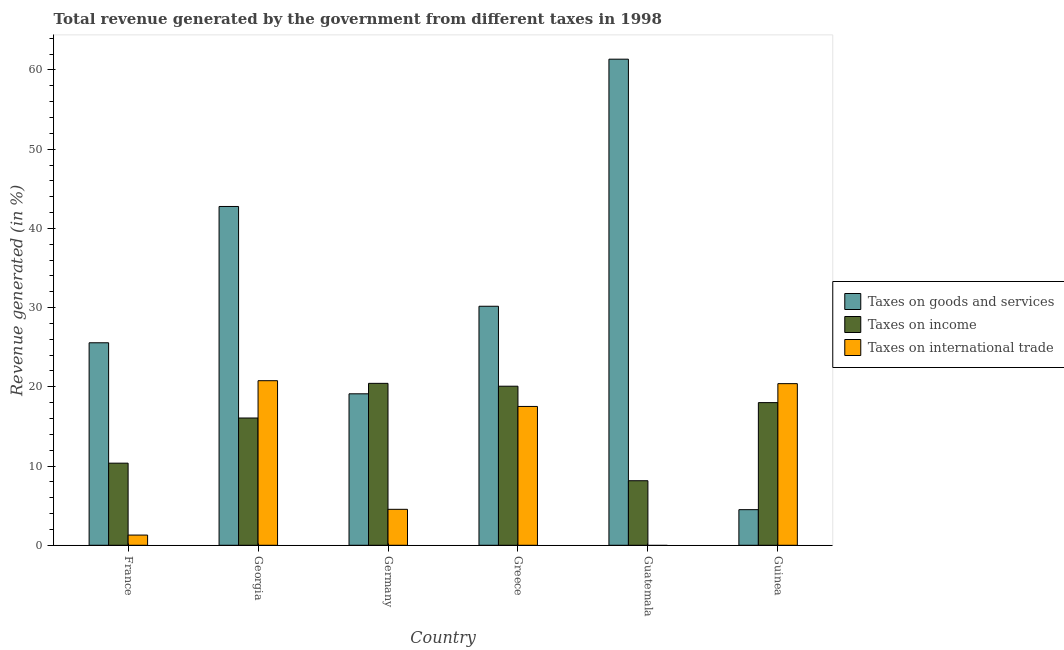How many groups of bars are there?
Your answer should be compact. 6. Are the number of bars per tick equal to the number of legend labels?
Give a very brief answer. No. Are the number of bars on each tick of the X-axis equal?
Provide a succinct answer. No. How many bars are there on the 1st tick from the left?
Your response must be concise. 3. How many bars are there on the 3rd tick from the right?
Provide a short and direct response. 3. What is the label of the 5th group of bars from the left?
Ensure brevity in your answer.  Guatemala. What is the percentage of revenue generated by tax on international trade in Guinea?
Keep it short and to the point. 20.4. Across all countries, what is the maximum percentage of revenue generated by taxes on goods and services?
Your answer should be compact. 61.36. Across all countries, what is the minimum percentage of revenue generated by taxes on goods and services?
Offer a very short reply. 4.5. In which country was the percentage of revenue generated by tax on international trade maximum?
Offer a terse response. Georgia. What is the total percentage of revenue generated by tax on international trade in the graph?
Provide a succinct answer. 64.53. What is the difference between the percentage of revenue generated by tax on international trade in France and that in Germany?
Ensure brevity in your answer.  -3.25. What is the difference between the percentage of revenue generated by taxes on goods and services in Georgia and the percentage of revenue generated by taxes on income in Greece?
Make the answer very short. 22.69. What is the average percentage of revenue generated by tax on international trade per country?
Ensure brevity in your answer.  10.75. What is the difference between the percentage of revenue generated by taxes on income and percentage of revenue generated by taxes on goods and services in Greece?
Make the answer very short. -10.09. In how many countries, is the percentage of revenue generated by taxes on goods and services greater than 48 %?
Your answer should be compact. 1. What is the ratio of the percentage of revenue generated by taxes on income in France to that in Georgia?
Keep it short and to the point. 0.65. Is the percentage of revenue generated by taxes on goods and services in Germany less than that in Guinea?
Keep it short and to the point. No. What is the difference between the highest and the second highest percentage of revenue generated by tax on international trade?
Give a very brief answer. 0.37. What is the difference between the highest and the lowest percentage of revenue generated by taxes on income?
Your response must be concise. 12.29. Is it the case that in every country, the sum of the percentage of revenue generated by taxes on goods and services and percentage of revenue generated by taxes on income is greater than the percentage of revenue generated by tax on international trade?
Your answer should be very brief. Yes. How many bars are there?
Your answer should be compact. 17. Are all the bars in the graph horizontal?
Keep it short and to the point. No. How many countries are there in the graph?
Provide a short and direct response. 6. Are the values on the major ticks of Y-axis written in scientific E-notation?
Your answer should be very brief. No. Does the graph contain any zero values?
Your answer should be very brief. Yes. How many legend labels are there?
Your answer should be very brief. 3. How are the legend labels stacked?
Provide a short and direct response. Vertical. What is the title of the graph?
Provide a succinct answer. Total revenue generated by the government from different taxes in 1998. What is the label or title of the Y-axis?
Provide a short and direct response. Revenue generated (in %). What is the Revenue generated (in %) in Taxes on goods and services in France?
Ensure brevity in your answer.  25.56. What is the Revenue generated (in %) in Taxes on income in France?
Make the answer very short. 10.37. What is the Revenue generated (in %) in Taxes on international trade in France?
Ensure brevity in your answer.  1.29. What is the Revenue generated (in %) in Taxes on goods and services in Georgia?
Keep it short and to the point. 42.77. What is the Revenue generated (in %) of Taxes on income in Georgia?
Provide a short and direct response. 16.06. What is the Revenue generated (in %) of Taxes on international trade in Georgia?
Keep it short and to the point. 20.77. What is the Revenue generated (in %) in Taxes on goods and services in Germany?
Your answer should be very brief. 19.12. What is the Revenue generated (in %) in Taxes on income in Germany?
Ensure brevity in your answer.  20.44. What is the Revenue generated (in %) in Taxes on international trade in Germany?
Give a very brief answer. 4.54. What is the Revenue generated (in %) in Taxes on goods and services in Greece?
Provide a succinct answer. 30.17. What is the Revenue generated (in %) of Taxes on income in Greece?
Provide a succinct answer. 20.08. What is the Revenue generated (in %) in Taxes on international trade in Greece?
Offer a terse response. 17.52. What is the Revenue generated (in %) of Taxes on goods and services in Guatemala?
Offer a terse response. 61.36. What is the Revenue generated (in %) of Taxes on income in Guatemala?
Your response must be concise. 8.15. What is the Revenue generated (in %) in Taxes on international trade in Guatemala?
Your response must be concise. 0. What is the Revenue generated (in %) of Taxes on goods and services in Guinea?
Your answer should be very brief. 4.5. What is the Revenue generated (in %) in Taxes on income in Guinea?
Provide a short and direct response. 18.01. What is the Revenue generated (in %) in Taxes on international trade in Guinea?
Offer a terse response. 20.4. Across all countries, what is the maximum Revenue generated (in %) in Taxes on goods and services?
Give a very brief answer. 61.36. Across all countries, what is the maximum Revenue generated (in %) in Taxes on income?
Provide a short and direct response. 20.44. Across all countries, what is the maximum Revenue generated (in %) in Taxes on international trade?
Offer a very short reply. 20.77. Across all countries, what is the minimum Revenue generated (in %) of Taxes on goods and services?
Your answer should be compact. 4.5. Across all countries, what is the minimum Revenue generated (in %) of Taxes on income?
Offer a terse response. 8.15. Across all countries, what is the minimum Revenue generated (in %) in Taxes on international trade?
Offer a terse response. 0. What is the total Revenue generated (in %) in Taxes on goods and services in the graph?
Keep it short and to the point. 183.47. What is the total Revenue generated (in %) in Taxes on income in the graph?
Make the answer very short. 93.1. What is the total Revenue generated (in %) of Taxes on international trade in the graph?
Provide a succinct answer. 64.53. What is the difference between the Revenue generated (in %) of Taxes on goods and services in France and that in Georgia?
Provide a succinct answer. -17.2. What is the difference between the Revenue generated (in %) in Taxes on income in France and that in Georgia?
Make the answer very short. -5.7. What is the difference between the Revenue generated (in %) of Taxes on international trade in France and that in Georgia?
Offer a terse response. -19.49. What is the difference between the Revenue generated (in %) in Taxes on goods and services in France and that in Germany?
Your response must be concise. 6.44. What is the difference between the Revenue generated (in %) of Taxes on income in France and that in Germany?
Make the answer very short. -10.07. What is the difference between the Revenue generated (in %) of Taxes on international trade in France and that in Germany?
Provide a succinct answer. -3.25. What is the difference between the Revenue generated (in %) in Taxes on goods and services in France and that in Greece?
Ensure brevity in your answer.  -4.61. What is the difference between the Revenue generated (in %) of Taxes on income in France and that in Greece?
Make the answer very short. -9.71. What is the difference between the Revenue generated (in %) in Taxes on international trade in France and that in Greece?
Give a very brief answer. -16.23. What is the difference between the Revenue generated (in %) of Taxes on goods and services in France and that in Guatemala?
Make the answer very short. -35.8. What is the difference between the Revenue generated (in %) of Taxes on income in France and that in Guatemala?
Make the answer very short. 2.22. What is the difference between the Revenue generated (in %) of Taxes on goods and services in France and that in Guinea?
Provide a succinct answer. 21.07. What is the difference between the Revenue generated (in %) of Taxes on income in France and that in Guinea?
Provide a short and direct response. -7.64. What is the difference between the Revenue generated (in %) in Taxes on international trade in France and that in Guinea?
Your answer should be very brief. -19.11. What is the difference between the Revenue generated (in %) of Taxes on goods and services in Georgia and that in Germany?
Your answer should be very brief. 23.65. What is the difference between the Revenue generated (in %) of Taxes on income in Georgia and that in Germany?
Give a very brief answer. -4.37. What is the difference between the Revenue generated (in %) of Taxes on international trade in Georgia and that in Germany?
Offer a terse response. 16.23. What is the difference between the Revenue generated (in %) of Taxes on goods and services in Georgia and that in Greece?
Give a very brief answer. 12.6. What is the difference between the Revenue generated (in %) in Taxes on income in Georgia and that in Greece?
Provide a short and direct response. -4.01. What is the difference between the Revenue generated (in %) in Taxes on international trade in Georgia and that in Greece?
Keep it short and to the point. 3.25. What is the difference between the Revenue generated (in %) of Taxes on goods and services in Georgia and that in Guatemala?
Provide a succinct answer. -18.59. What is the difference between the Revenue generated (in %) in Taxes on income in Georgia and that in Guatemala?
Offer a terse response. 7.92. What is the difference between the Revenue generated (in %) of Taxes on goods and services in Georgia and that in Guinea?
Provide a short and direct response. 38.27. What is the difference between the Revenue generated (in %) of Taxes on income in Georgia and that in Guinea?
Your answer should be compact. -1.94. What is the difference between the Revenue generated (in %) in Taxes on international trade in Georgia and that in Guinea?
Keep it short and to the point. 0.37. What is the difference between the Revenue generated (in %) in Taxes on goods and services in Germany and that in Greece?
Provide a succinct answer. -11.05. What is the difference between the Revenue generated (in %) in Taxes on income in Germany and that in Greece?
Keep it short and to the point. 0.36. What is the difference between the Revenue generated (in %) in Taxes on international trade in Germany and that in Greece?
Provide a short and direct response. -12.98. What is the difference between the Revenue generated (in %) of Taxes on goods and services in Germany and that in Guatemala?
Your answer should be very brief. -42.24. What is the difference between the Revenue generated (in %) in Taxes on income in Germany and that in Guatemala?
Provide a short and direct response. 12.29. What is the difference between the Revenue generated (in %) in Taxes on goods and services in Germany and that in Guinea?
Keep it short and to the point. 14.62. What is the difference between the Revenue generated (in %) in Taxes on income in Germany and that in Guinea?
Your response must be concise. 2.43. What is the difference between the Revenue generated (in %) of Taxes on international trade in Germany and that in Guinea?
Your response must be concise. -15.86. What is the difference between the Revenue generated (in %) in Taxes on goods and services in Greece and that in Guatemala?
Your answer should be compact. -31.19. What is the difference between the Revenue generated (in %) in Taxes on income in Greece and that in Guatemala?
Offer a terse response. 11.93. What is the difference between the Revenue generated (in %) in Taxes on goods and services in Greece and that in Guinea?
Provide a succinct answer. 25.67. What is the difference between the Revenue generated (in %) in Taxes on income in Greece and that in Guinea?
Provide a short and direct response. 2.07. What is the difference between the Revenue generated (in %) of Taxes on international trade in Greece and that in Guinea?
Give a very brief answer. -2.88. What is the difference between the Revenue generated (in %) of Taxes on goods and services in Guatemala and that in Guinea?
Keep it short and to the point. 56.86. What is the difference between the Revenue generated (in %) of Taxes on income in Guatemala and that in Guinea?
Make the answer very short. -9.86. What is the difference between the Revenue generated (in %) of Taxes on goods and services in France and the Revenue generated (in %) of Taxes on income in Georgia?
Ensure brevity in your answer.  9.5. What is the difference between the Revenue generated (in %) of Taxes on goods and services in France and the Revenue generated (in %) of Taxes on international trade in Georgia?
Keep it short and to the point. 4.79. What is the difference between the Revenue generated (in %) of Taxes on income in France and the Revenue generated (in %) of Taxes on international trade in Georgia?
Ensure brevity in your answer.  -10.41. What is the difference between the Revenue generated (in %) in Taxes on goods and services in France and the Revenue generated (in %) in Taxes on income in Germany?
Make the answer very short. 5.12. What is the difference between the Revenue generated (in %) of Taxes on goods and services in France and the Revenue generated (in %) of Taxes on international trade in Germany?
Ensure brevity in your answer.  21.02. What is the difference between the Revenue generated (in %) of Taxes on income in France and the Revenue generated (in %) of Taxes on international trade in Germany?
Your response must be concise. 5.83. What is the difference between the Revenue generated (in %) of Taxes on goods and services in France and the Revenue generated (in %) of Taxes on income in Greece?
Your answer should be compact. 5.48. What is the difference between the Revenue generated (in %) of Taxes on goods and services in France and the Revenue generated (in %) of Taxes on international trade in Greece?
Offer a terse response. 8.04. What is the difference between the Revenue generated (in %) in Taxes on income in France and the Revenue generated (in %) in Taxes on international trade in Greece?
Your response must be concise. -7.16. What is the difference between the Revenue generated (in %) in Taxes on goods and services in France and the Revenue generated (in %) in Taxes on income in Guatemala?
Provide a short and direct response. 17.41. What is the difference between the Revenue generated (in %) in Taxes on goods and services in France and the Revenue generated (in %) in Taxes on income in Guinea?
Provide a succinct answer. 7.55. What is the difference between the Revenue generated (in %) in Taxes on goods and services in France and the Revenue generated (in %) in Taxes on international trade in Guinea?
Keep it short and to the point. 5.16. What is the difference between the Revenue generated (in %) of Taxes on income in France and the Revenue generated (in %) of Taxes on international trade in Guinea?
Provide a succinct answer. -10.04. What is the difference between the Revenue generated (in %) in Taxes on goods and services in Georgia and the Revenue generated (in %) in Taxes on income in Germany?
Offer a very short reply. 22.33. What is the difference between the Revenue generated (in %) in Taxes on goods and services in Georgia and the Revenue generated (in %) in Taxes on international trade in Germany?
Provide a succinct answer. 38.23. What is the difference between the Revenue generated (in %) in Taxes on income in Georgia and the Revenue generated (in %) in Taxes on international trade in Germany?
Make the answer very short. 11.53. What is the difference between the Revenue generated (in %) in Taxes on goods and services in Georgia and the Revenue generated (in %) in Taxes on income in Greece?
Your answer should be very brief. 22.69. What is the difference between the Revenue generated (in %) of Taxes on goods and services in Georgia and the Revenue generated (in %) of Taxes on international trade in Greece?
Provide a succinct answer. 25.24. What is the difference between the Revenue generated (in %) in Taxes on income in Georgia and the Revenue generated (in %) in Taxes on international trade in Greece?
Ensure brevity in your answer.  -1.46. What is the difference between the Revenue generated (in %) of Taxes on goods and services in Georgia and the Revenue generated (in %) of Taxes on income in Guatemala?
Your response must be concise. 34.62. What is the difference between the Revenue generated (in %) in Taxes on goods and services in Georgia and the Revenue generated (in %) in Taxes on income in Guinea?
Give a very brief answer. 24.76. What is the difference between the Revenue generated (in %) in Taxes on goods and services in Georgia and the Revenue generated (in %) in Taxes on international trade in Guinea?
Give a very brief answer. 22.36. What is the difference between the Revenue generated (in %) in Taxes on income in Georgia and the Revenue generated (in %) in Taxes on international trade in Guinea?
Offer a very short reply. -4.34. What is the difference between the Revenue generated (in %) of Taxes on goods and services in Germany and the Revenue generated (in %) of Taxes on income in Greece?
Give a very brief answer. -0.96. What is the difference between the Revenue generated (in %) in Taxes on goods and services in Germany and the Revenue generated (in %) in Taxes on international trade in Greece?
Make the answer very short. 1.6. What is the difference between the Revenue generated (in %) in Taxes on income in Germany and the Revenue generated (in %) in Taxes on international trade in Greece?
Ensure brevity in your answer.  2.92. What is the difference between the Revenue generated (in %) of Taxes on goods and services in Germany and the Revenue generated (in %) of Taxes on income in Guatemala?
Provide a succinct answer. 10.97. What is the difference between the Revenue generated (in %) of Taxes on goods and services in Germany and the Revenue generated (in %) of Taxes on income in Guinea?
Your response must be concise. 1.11. What is the difference between the Revenue generated (in %) in Taxes on goods and services in Germany and the Revenue generated (in %) in Taxes on international trade in Guinea?
Offer a terse response. -1.28. What is the difference between the Revenue generated (in %) in Taxes on income in Germany and the Revenue generated (in %) in Taxes on international trade in Guinea?
Provide a succinct answer. 0.04. What is the difference between the Revenue generated (in %) in Taxes on goods and services in Greece and the Revenue generated (in %) in Taxes on income in Guatemala?
Your answer should be compact. 22.02. What is the difference between the Revenue generated (in %) of Taxes on goods and services in Greece and the Revenue generated (in %) of Taxes on income in Guinea?
Your answer should be very brief. 12.16. What is the difference between the Revenue generated (in %) in Taxes on goods and services in Greece and the Revenue generated (in %) in Taxes on international trade in Guinea?
Ensure brevity in your answer.  9.77. What is the difference between the Revenue generated (in %) in Taxes on income in Greece and the Revenue generated (in %) in Taxes on international trade in Guinea?
Offer a very short reply. -0.32. What is the difference between the Revenue generated (in %) of Taxes on goods and services in Guatemala and the Revenue generated (in %) of Taxes on income in Guinea?
Offer a very short reply. 43.35. What is the difference between the Revenue generated (in %) of Taxes on goods and services in Guatemala and the Revenue generated (in %) of Taxes on international trade in Guinea?
Your response must be concise. 40.96. What is the difference between the Revenue generated (in %) in Taxes on income in Guatemala and the Revenue generated (in %) in Taxes on international trade in Guinea?
Ensure brevity in your answer.  -12.25. What is the average Revenue generated (in %) in Taxes on goods and services per country?
Your response must be concise. 30.58. What is the average Revenue generated (in %) of Taxes on income per country?
Make the answer very short. 15.52. What is the average Revenue generated (in %) in Taxes on international trade per country?
Ensure brevity in your answer.  10.75. What is the difference between the Revenue generated (in %) in Taxes on goods and services and Revenue generated (in %) in Taxes on income in France?
Your answer should be compact. 15.2. What is the difference between the Revenue generated (in %) in Taxes on goods and services and Revenue generated (in %) in Taxes on international trade in France?
Provide a succinct answer. 24.27. What is the difference between the Revenue generated (in %) of Taxes on income and Revenue generated (in %) of Taxes on international trade in France?
Make the answer very short. 9.08. What is the difference between the Revenue generated (in %) in Taxes on goods and services and Revenue generated (in %) in Taxes on income in Georgia?
Your response must be concise. 26.7. What is the difference between the Revenue generated (in %) of Taxes on goods and services and Revenue generated (in %) of Taxes on international trade in Georgia?
Keep it short and to the point. 21.99. What is the difference between the Revenue generated (in %) in Taxes on income and Revenue generated (in %) in Taxes on international trade in Georgia?
Your response must be concise. -4.71. What is the difference between the Revenue generated (in %) of Taxes on goods and services and Revenue generated (in %) of Taxes on income in Germany?
Your answer should be very brief. -1.32. What is the difference between the Revenue generated (in %) of Taxes on goods and services and Revenue generated (in %) of Taxes on international trade in Germany?
Ensure brevity in your answer.  14.58. What is the difference between the Revenue generated (in %) in Taxes on income and Revenue generated (in %) in Taxes on international trade in Germany?
Keep it short and to the point. 15.9. What is the difference between the Revenue generated (in %) in Taxes on goods and services and Revenue generated (in %) in Taxes on income in Greece?
Provide a succinct answer. 10.09. What is the difference between the Revenue generated (in %) of Taxes on goods and services and Revenue generated (in %) of Taxes on international trade in Greece?
Your response must be concise. 12.65. What is the difference between the Revenue generated (in %) of Taxes on income and Revenue generated (in %) of Taxes on international trade in Greece?
Keep it short and to the point. 2.55. What is the difference between the Revenue generated (in %) of Taxes on goods and services and Revenue generated (in %) of Taxes on income in Guatemala?
Ensure brevity in your answer.  53.21. What is the difference between the Revenue generated (in %) of Taxes on goods and services and Revenue generated (in %) of Taxes on income in Guinea?
Your response must be concise. -13.51. What is the difference between the Revenue generated (in %) of Taxes on goods and services and Revenue generated (in %) of Taxes on international trade in Guinea?
Offer a very short reply. -15.91. What is the difference between the Revenue generated (in %) in Taxes on income and Revenue generated (in %) in Taxes on international trade in Guinea?
Your answer should be very brief. -2.39. What is the ratio of the Revenue generated (in %) in Taxes on goods and services in France to that in Georgia?
Provide a succinct answer. 0.6. What is the ratio of the Revenue generated (in %) in Taxes on income in France to that in Georgia?
Provide a succinct answer. 0.65. What is the ratio of the Revenue generated (in %) in Taxes on international trade in France to that in Georgia?
Make the answer very short. 0.06. What is the ratio of the Revenue generated (in %) of Taxes on goods and services in France to that in Germany?
Provide a succinct answer. 1.34. What is the ratio of the Revenue generated (in %) in Taxes on income in France to that in Germany?
Your answer should be compact. 0.51. What is the ratio of the Revenue generated (in %) in Taxes on international trade in France to that in Germany?
Provide a short and direct response. 0.28. What is the ratio of the Revenue generated (in %) of Taxes on goods and services in France to that in Greece?
Provide a short and direct response. 0.85. What is the ratio of the Revenue generated (in %) in Taxes on income in France to that in Greece?
Your answer should be very brief. 0.52. What is the ratio of the Revenue generated (in %) of Taxes on international trade in France to that in Greece?
Your answer should be very brief. 0.07. What is the ratio of the Revenue generated (in %) of Taxes on goods and services in France to that in Guatemala?
Offer a very short reply. 0.42. What is the ratio of the Revenue generated (in %) of Taxes on income in France to that in Guatemala?
Keep it short and to the point. 1.27. What is the ratio of the Revenue generated (in %) of Taxes on goods and services in France to that in Guinea?
Keep it short and to the point. 5.69. What is the ratio of the Revenue generated (in %) in Taxes on income in France to that in Guinea?
Offer a very short reply. 0.58. What is the ratio of the Revenue generated (in %) in Taxes on international trade in France to that in Guinea?
Your answer should be very brief. 0.06. What is the ratio of the Revenue generated (in %) in Taxes on goods and services in Georgia to that in Germany?
Your answer should be compact. 2.24. What is the ratio of the Revenue generated (in %) in Taxes on income in Georgia to that in Germany?
Provide a short and direct response. 0.79. What is the ratio of the Revenue generated (in %) in Taxes on international trade in Georgia to that in Germany?
Offer a terse response. 4.58. What is the ratio of the Revenue generated (in %) of Taxes on goods and services in Georgia to that in Greece?
Your answer should be very brief. 1.42. What is the ratio of the Revenue generated (in %) in Taxes on income in Georgia to that in Greece?
Provide a succinct answer. 0.8. What is the ratio of the Revenue generated (in %) of Taxes on international trade in Georgia to that in Greece?
Offer a very short reply. 1.19. What is the ratio of the Revenue generated (in %) in Taxes on goods and services in Georgia to that in Guatemala?
Keep it short and to the point. 0.7. What is the ratio of the Revenue generated (in %) in Taxes on income in Georgia to that in Guatemala?
Provide a succinct answer. 1.97. What is the ratio of the Revenue generated (in %) of Taxes on goods and services in Georgia to that in Guinea?
Offer a terse response. 9.51. What is the ratio of the Revenue generated (in %) of Taxes on income in Georgia to that in Guinea?
Your answer should be very brief. 0.89. What is the ratio of the Revenue generated (in %) of Taxes on international trade in Georgia to that in Guinea?
Provide a short and direct response. 1.02. What is the ratio of the Revenue generated (in %) of Taxes on goods and services in Germany to that in Greece?
Offer a very short reply. 0.63. What is the ratio of the Revenue generated (in %) of Taxes on income in Germany to that in Greece?
Your answer should be compact. 1.02. What is the ratio of the Revenue generated (in %) of Taxes on international trade in Germany to that in Greece?
Provide a succinct answer. 0.26. What is the ratio of the Revenue generated (in %) in Taxes on goods and services in Germany to that in Guatemala?
Provide a succinct answer. 0.31. What is the ratio of the Revenue generated (in %) in Taxes on income in Germany to that in Guatemala?
Provide a short and direct response. 2.51. What is the ratio of the Revenue generated (in %) of Taxes on goods and services in Germany to that in Guinea?
Offer a terse response. 4.25. What is the ratio of the Revenue generated (in %) of Taxes on income in Germany to that in Guinea?
Offer a very short reply. 1.14. What is the ratio of the Revenue generated (in %) of Taxes on international trade in Germany to that in Guinea?
Keep it short and to the point. 0.22. What is the ratio of the Revenue generated (in %) of Taxes on goods and services in Greece to that in Guatemala?
Keep it short and to the point. 0.49. What is the ratio of the Revenue generated (in %) of Taxes on income in Greece to that in Guatemala?
Provide a short and direct response. 2.46. What is the ratio of the Revenue generated (in %) of Taxes on goods and services in Greece to that in Guinea?
Your response must be concise. 6.71. What is the ratio of the Revenue generated (in %) of Taxes on income in Greece to that in Guinea?
Your response must be concise. 1.11. What is the ratio of the Revenue generated (in %) of Taxes on international trade in Greece to that in Guinea?
Ensure brevity in your answer.  0.86. What is the ratio of the Revenue generated (in %) in Taxes on goods and services in Guatemala to that in Guinea?
Ensure brevity in your answer.  13.65. What is the ratio of the Revenue generated (in %) of Taxes on income in Guatemala to that in Guinea?
Offer a very short reply. 0.45. What is the difference between the highest and the second highest Revenue generated (in %) of Taxes on goods and services?
Offer a terse response. 18.59. What is the difference between the highest and the second highest Revenue generated (in %) of Taxes on income?
Give a very brief answer. 0.36. What is the difference between the highest and the second highest Revenue generated (in %) of Taxes on international trade?
Keep it short and to the point. 0.37. What is the difference between the highest and the lowest Revenue generated (in %) in Taxes on goods and services?
Provide a short and direct response. 56.86. What is the difference between the highest and the lowest Revenue generated (in %) in Taxes on income?
Make the answer very short. 12.29. What is the difference between the highest and the lowest Revenue generated (in %) in Taxes on international trade?
Offer a terse response. 20.77. 